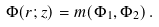Convert formula to latex. <formula><loc_0><loc_0><loc_500><loc_500>\Phi ( { r } ; z ) = m ( \Phi _ { 1 } , \Phi _ { 2 } ) \, .</formula> 